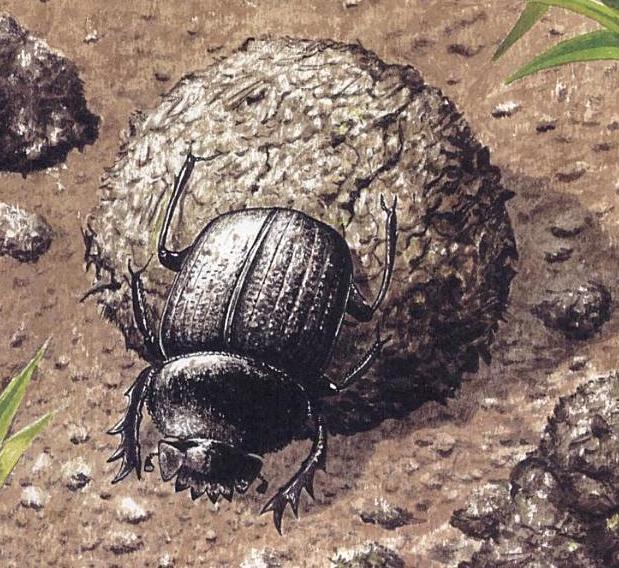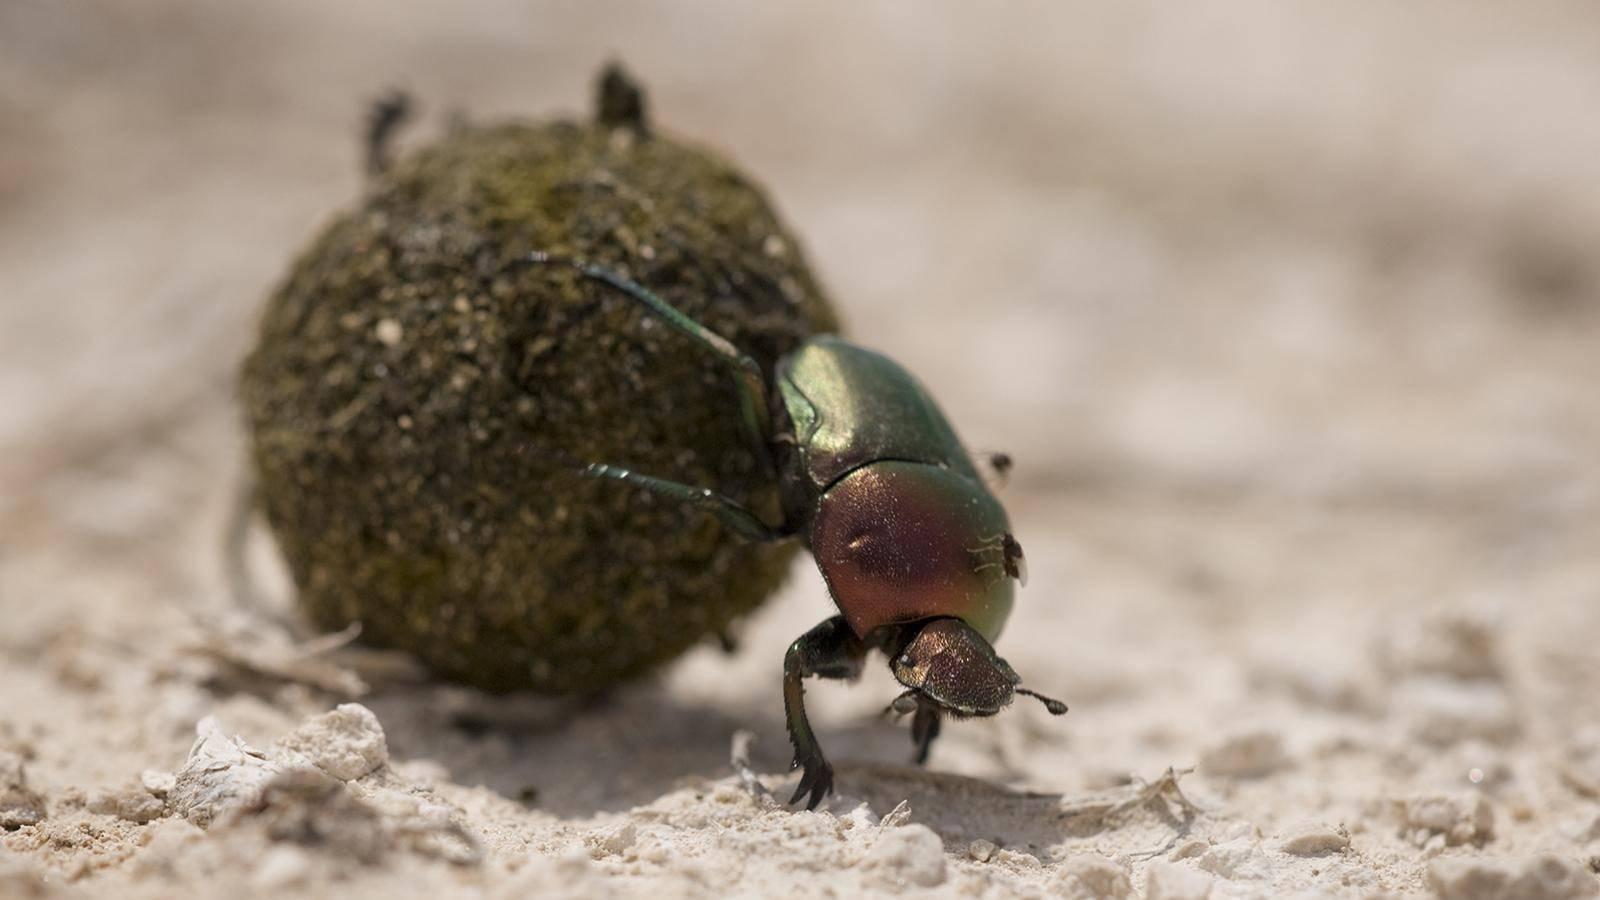The first image is the image on the left, the second image is the image on the right. Evaluate the accuracy of this statement regarding the images: "There are two dung beetles in the image on the right.". Is it true? Answer yes or no. No. The first image is the image on the left, the second image is the image on the right. Assess this claim about the two images: "There are at least three beetles.". Correct or not? Answer yes or no. No. 